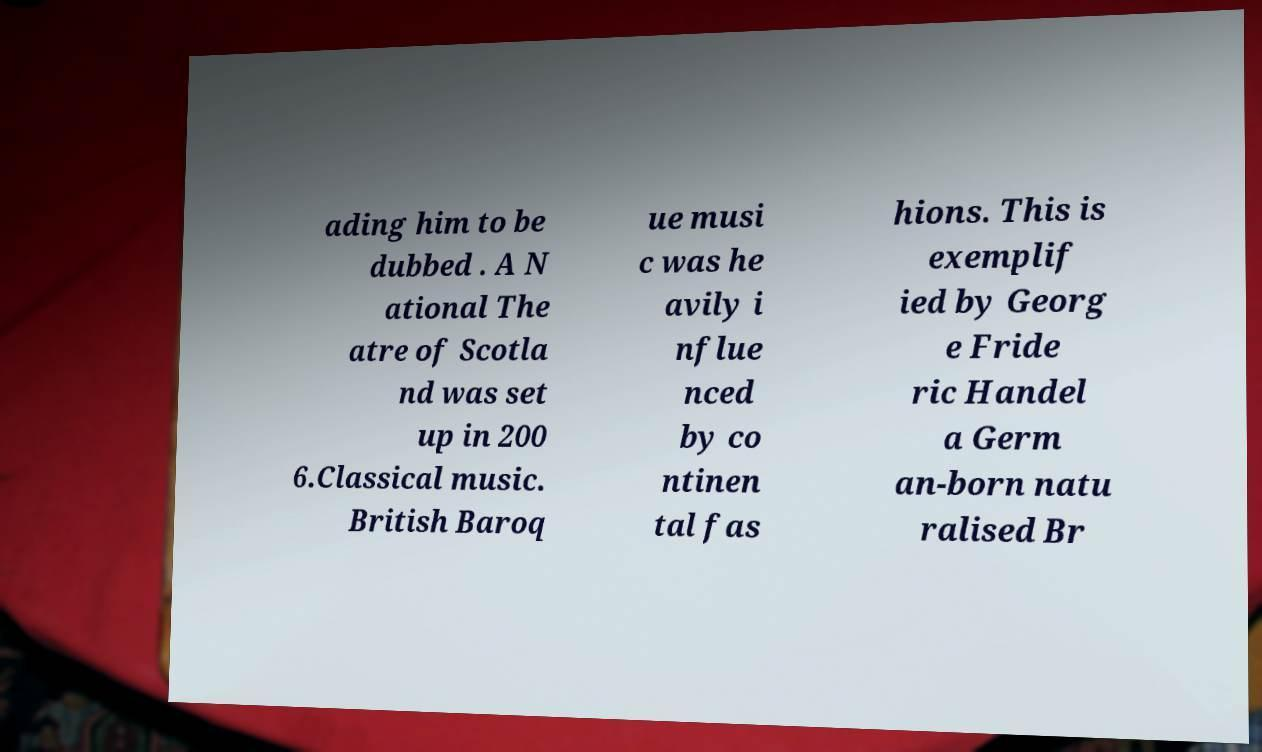Could you extract and type out the text from this image? ading him to be dubbed . A N ational The atre of Scotla nd was set up in 200 6.Classical music. British Baroq ue musi c was he avily i nflue nced by co ntinen tal fas hions. This is exemplif ied by Georg e Fride ric Handel a Germ an-born natu ralised Br 